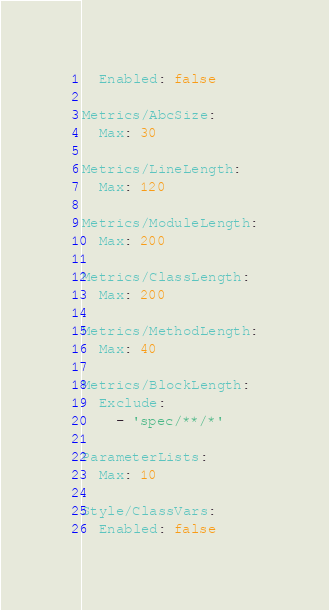<code> <loc_0><loc_0><loc_500><loc_500><_YAML_>  Enabled: false

Metrics/AbcSize:
  Max: 30

Metrics/LineLength:
  Max: 120

Metrics/ModuleLength:
  Max: 200

Metrics/ClassLength:
  Max: 200

Metrics/MethodLength:
  Max: 40

Metrics/BlockLength:
  Exclude:
    - 'spec/**/*'

ParameterLists:
  Max: 10

Style/ClassVars:
  Enabled: false
</code> 